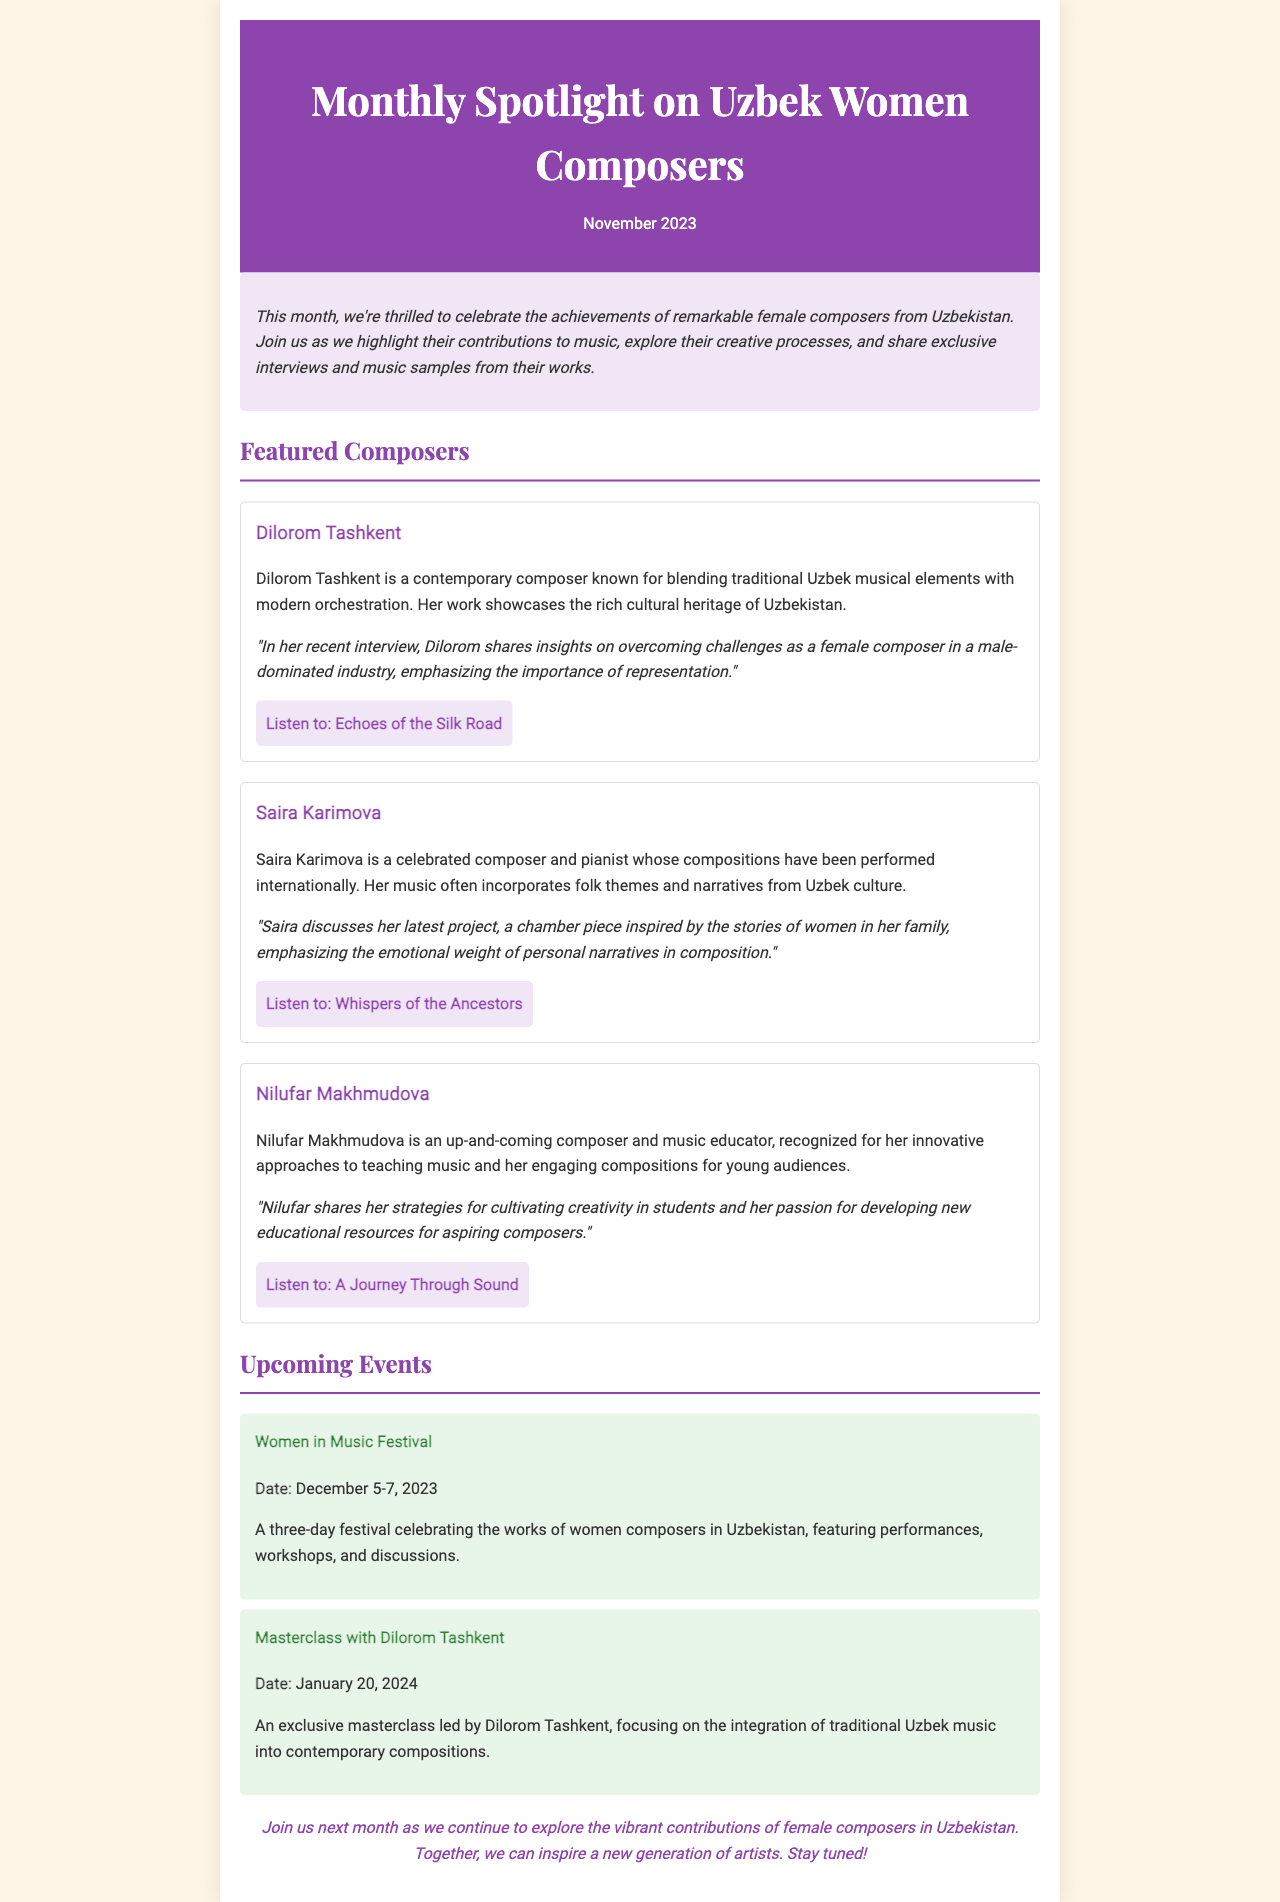What is the title of the newsletter? The title is prominently displayed at the top of the document, which is "Monthly Spotlight on Uzbek Women Composers."
Answer: Monthly Spotlight on Uzbek Women Composers Who is the featured composer known for blending traditional and modern music? The composer known for this style, as mentioned in the document, is Dilorom Tashkent.
Answer: Dilorom Tashkent What date is the Women in Music Festival scheduled? The document lists the date of the festival as December 5-7, 2023.
Answer: December 5-7, 2023 What piece did Saira Karimova discuss in her interview? According to the document, Saira discussed a chamber piece inspired by the stories of women in her family.
Answer: A chamber piece inspired by the stories of women in her family When will the masterclass with Dilorom Tashkent take place? The document indicates that the masterclass is scheduled for January 20, 2024.
Answer: January 20, 2024 Which composer focuses on developing educational resources for young audiences? The document states that this composer is Nilufar Makhmudova.
Answer: Nilufar Makhmudova What is emphasized in Dilorom's interview regarding female composers? The document highlights Dilorom's emphasis on overcoming challenges and the importance of representation.
Answer: Overcoming challenges and the importance of representation What color is used for the header background? The header background color mentioned in the document is #8E44AD.
Answer: #8E44AD 